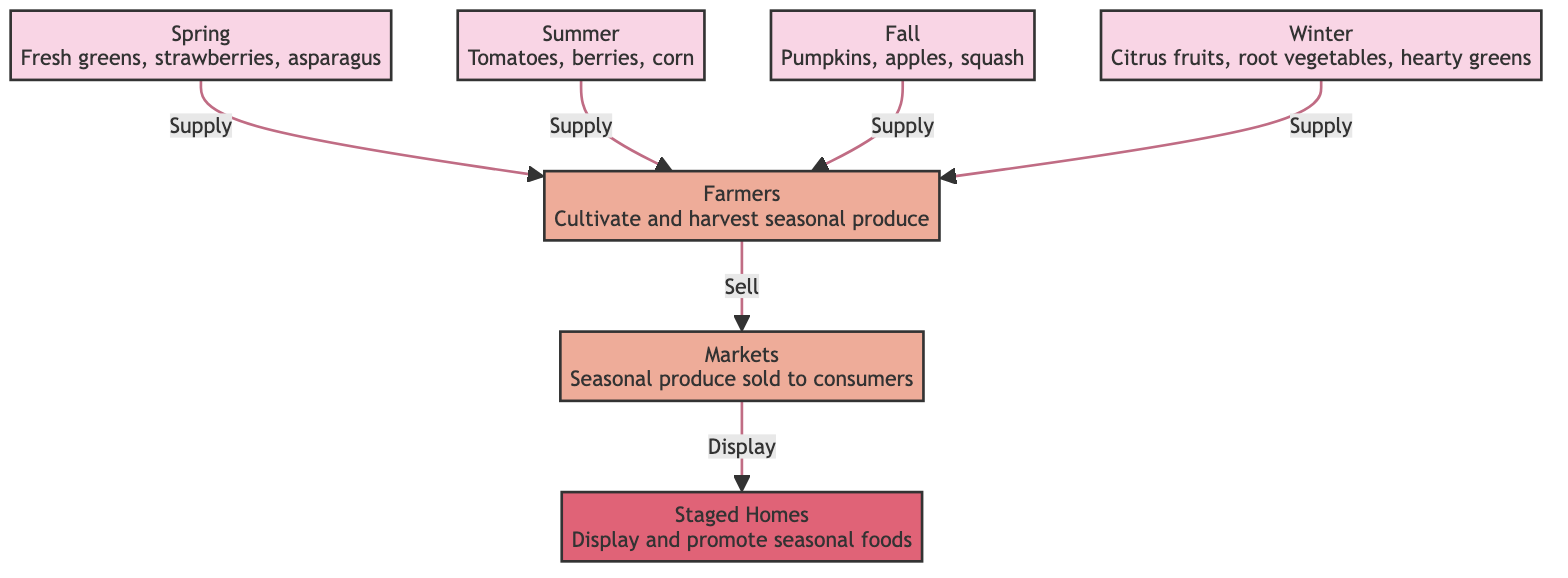What are the seasonal foods available in Summer? The diagram shows that during Summer, the available foods are tomatoes, berries, and corn. This information is listed directly under the Summer node.
Answer: Tomatoes, berries, corn Who cultivates and harvests seasonal produce? The diagram clearly states that farmers are responsible for cultivating and harvesting seasonal produce. This is indicated in the actor node labeled "Farmers."
Answer: Farmers How many seasons are represented in the diagram? In the diagram, there are four distinct seasons represented: Spring, Summer, Fall, and Winter. Each season is shown as a separate node, indicating a total of four nodes for the seasons.
Answer: 4 What type of foods are displayed in staged homes during Winter? According to the diagram, during Winter, the foods displayed in staged homes include citrus fruits, root vegetables, and hearty greens. This information is listed directly under the Winter node.
Answer: Citrus fruits, root vegetables, hearty greens What is the relationship between farmers and markets? The diagram shows that farmers supply seasonal produce to markets, which is indicated by the directed edge labeled "Sell" connecting the Farmers node and the Markets node.
Answer: Supply Which season provides pumpkins as a seasonal food? Fall is the season that provides pumpkins, as indicated in the node labeled "Fall," which lists pumpkins, apples, and squash as available foods.
Answer: Fall How do markets interact with staged homes? The diagram indicates that markets sell seasonal produce to consumers, who are represented in the staged homes, creating a direct relationship where markets provide food for display in staged homes, as indicated by the "Display" edge.
Answer: Sell What type of foods appears in staged homes during Spring? The foods displayed in staged homes during Spring are fresh greens, strawberries, and asparagus, indicated directly under the Spring node in the diagram.
Answer: Fresh greens, strawberries, asparagus What do staged homes do with seasonal foods? Staged homes display and promote seasonal foods as indicated by the "Display" relationship connecting the Markets node to the Staged Homes node. This relationship highlights the role of staged homes in showcasing the available seasonal foods.
Answer: Display 